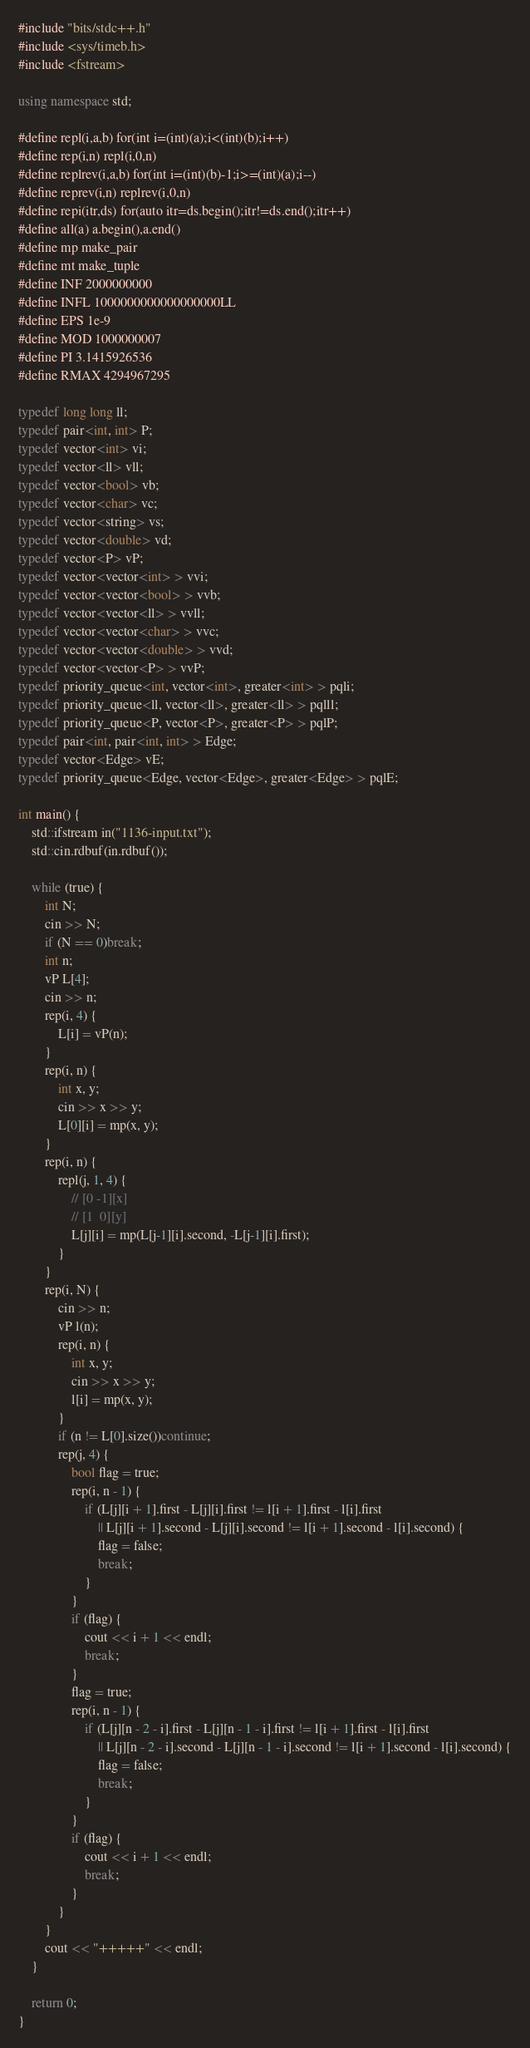Convert code to text. <code><loc_0><loc_0><loc_500><loc_500><_C++_>#include "bits/stdc++.h"
#include <sys/timeb.h>
#include <fstream>

using namespace std;

#define repl(i,a,b) for(int i=(int)(a);i<(int)(b);i++)
#define rep(i,n) repl(i,0,n)
#define replrev(i,a,b) for(int i=(int)(b)-1;i>=(int)(a);i--)
#define reprev(i,n) replrev(i,0,n)
#define repi(itr,ds) for(auto itr=ds.begin();itr!=ds.end();itr++)
#define all(a) a.begin(),a.end()
#define mp make_pair
#define mt make_tuple
#define INF 2000000000
#define INFL 1000000000000000000LL
#define EPS 1e-9
#define MOD 1000000007
#define PI 3.1415926536
#define RMAX 4294967295

typedef long long ll;
typedef pair<int, int> P;
typedef vector<int> vi;
typedef vector<ll> vll;
typedef vector<bool> vb;
typedef vector<char> vc;
typedef vector<string> vs;
typedef vector<double> vd;
typedef vector<P> vP;
typedef vector<vector<int> > vvi;
typedef vector<vector<bool> > vvb;
typedef vector<vector<ll> > vvll;
typedef vector<vector<char> > vvc;
typedef vector<vector<double> > vvd;
typedef vector<vector<P> > vvP;
typedef priority_queue<int, vector<int>, greater<int> > pqli;
typedef priority_queue<ll, vector<ll>, greater<ll> > pqlll;
typedef priority_queue<P, vector<P>, greater<P> > pqlP;
typedef pair<int, pair<int, int> > Edge;
typedef vector<Edge> vE;
typedef priority_queue<Edge, vector<Edge>, greater<Edge> > pqlE;

int main() {
	std::ifstream in("1136-input.txt");
	std::cin.rdbuf(in.rdbuf());

	while (true) {
		int N;
		cin >> N;
		if (N == 0)break;
		int n;
		vP L[4];
		cin >> n;
		rep(i, 4) {
			L[i] = vP(n);
		}
		rep(i, n) {
			int x, y;
			cin >> x >> y;
			L[0][i] = mp(x, y);
		}
		rep(i, n) {
			repl(j, 1, 4) {
				// [0 -1][x]
				// [1  0][y]
				L[j][i] = mp(L[j-1][i].second, -L[j-1][i].first);
			}
		}
		rep(i, N) {
			cin >> n;
			vP l(n);
			rep(i, n) {
				int x, y;
				cin >> x >> y;
				l[i] = mp(x, y);
			}
			if (n != L[0].size())continue;
			rep(j, 4) {
				bool flag = true;
				rep(i, n - 1) {
					if (L[j][i + 1].first - L[j][i].first != l[i + 1].first - l[i].first
						|| L[j][i + 1].second - L[j][i].second != l[i + 1].second - l[i].second) {
						flag = false;
						break;
					}
				}
				if (flag) {
					cout << i + 1 << endl;
					break;
				}
				flag = true;
				rep(i, n - 1) {
					if (L[j][n - 2 - i].first - L[j][n - 1 - i].first != l[i + 1].first - l[i].first
						|| L[j][n - 2 - i].second - L[j][n - 1 - i].second != l[i + 1].second - l[i].second) {
						flag = false;
						break;
					}
				}
				if (flag) {
					cout << i + 1 << endl;
					break;
				}
			}
		}
		cout << "+++++" << endl;
	}

	return 0;
}</code> 